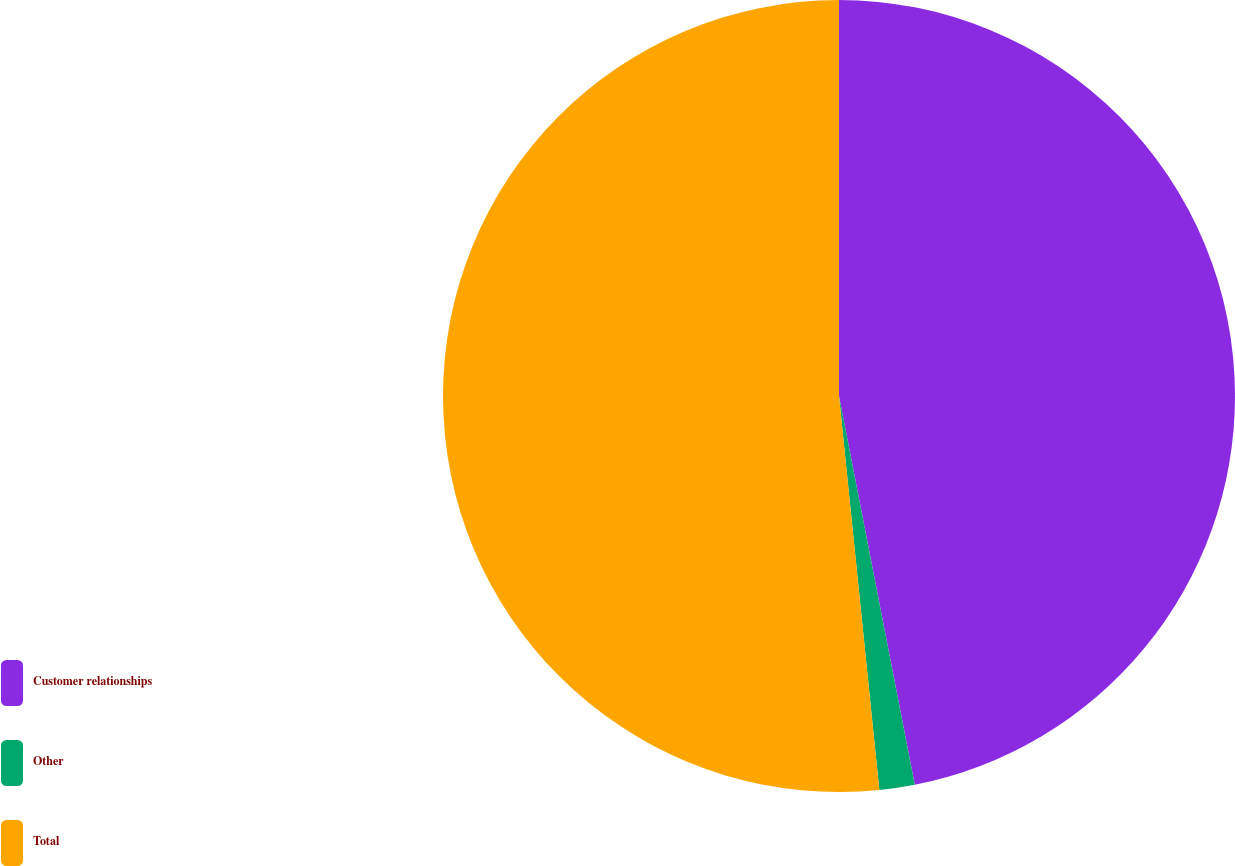<chart> <loc_0><loc_0><loc_500><loc_500><pie_chart><fcel>Customer relationships<fcel>Other<fcel>Total<nl><fcel>46.94%<fcel>1.44%<fcel>51.63%<nl></chart> 